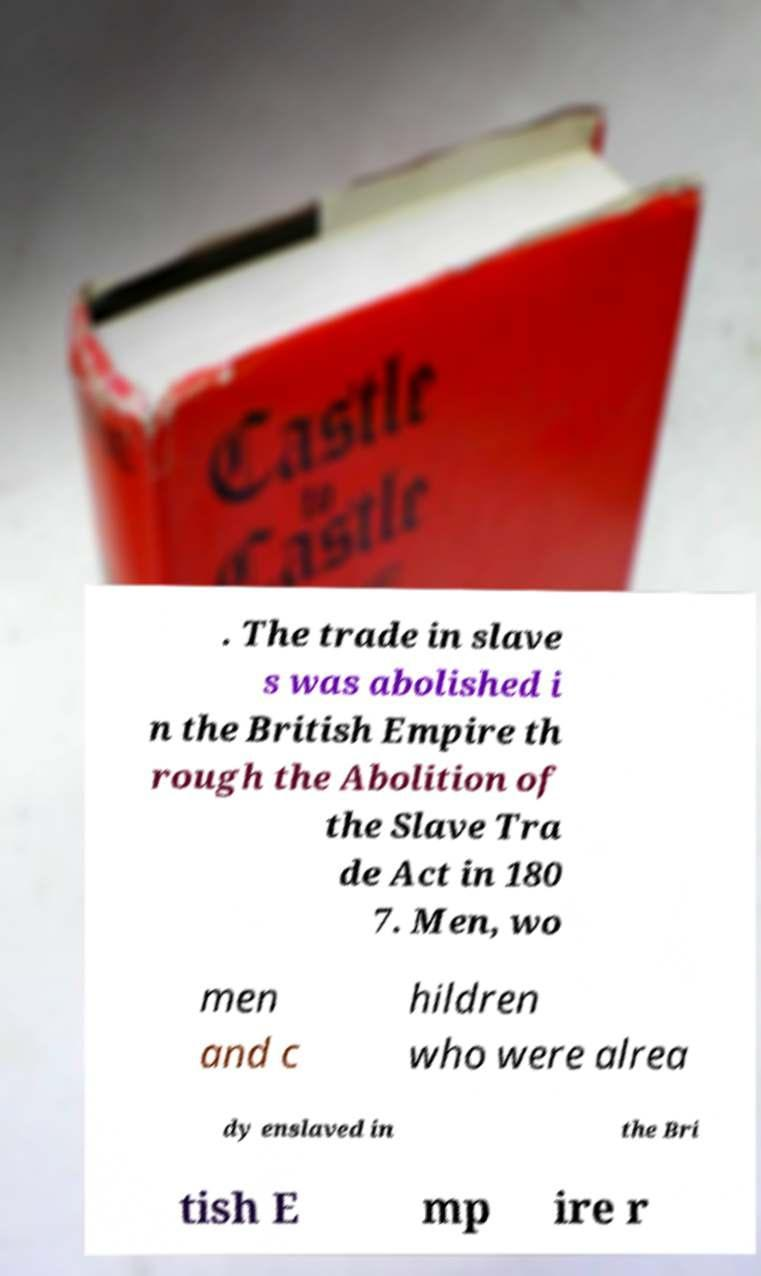Please read and relay the text visible in this image. What does it say? . The trade in slave s was abolished i n the British Empire th rough the Abolition of the Slave Tra de Act in 180 7. Men, wo men and c hildren who were alrea dy enslaved in the Bri tish E mp ire r 